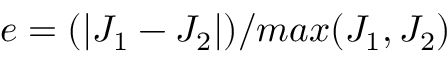<formula> <loc_0><loc_0><loc_500><loc_500>e = ( | J _ { 1 } - J _ { 2 } | ) / \max ( J _ { 1 } , J _ { 2 } )</formula> 